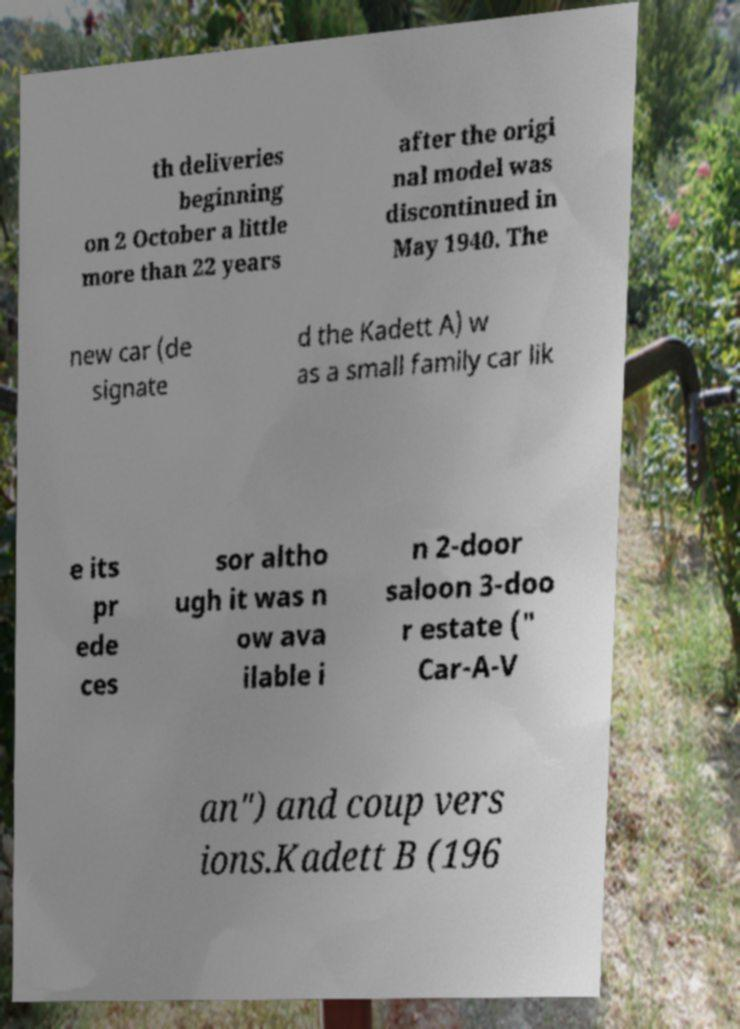Can you read and provide the text displayed in the image?This photo seems to have some interesting text. Can you extract and type it out for me? th deliveries beginning on 2 October a little more than 22 years after the origi nal model was discontinued in May 1940. The new car (de signate d the Kadett A) w as a small family car lik e its pr ede ces sor altho ugh it was n ow ava ilable i n 2-door saloon 3-doo r estate (" Car-A-V an") and coup vers ions.Kadett B (196 